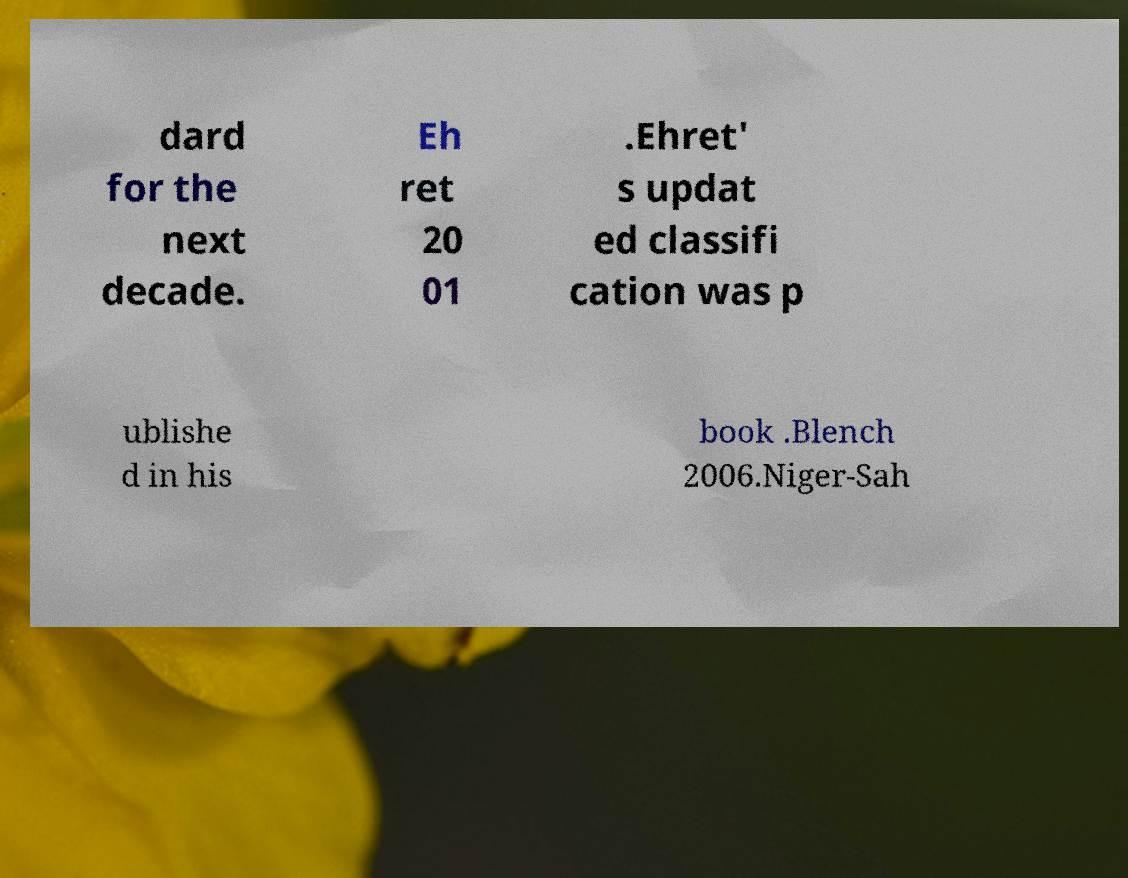What messages or text are displayed in this image? I need them in a readable, typed format. dard for the next decade. Eh ret 20 01 .Ehret' s updat ed classifi cation was p ublishe d in his book .Blench 2006.Niger-Sah 